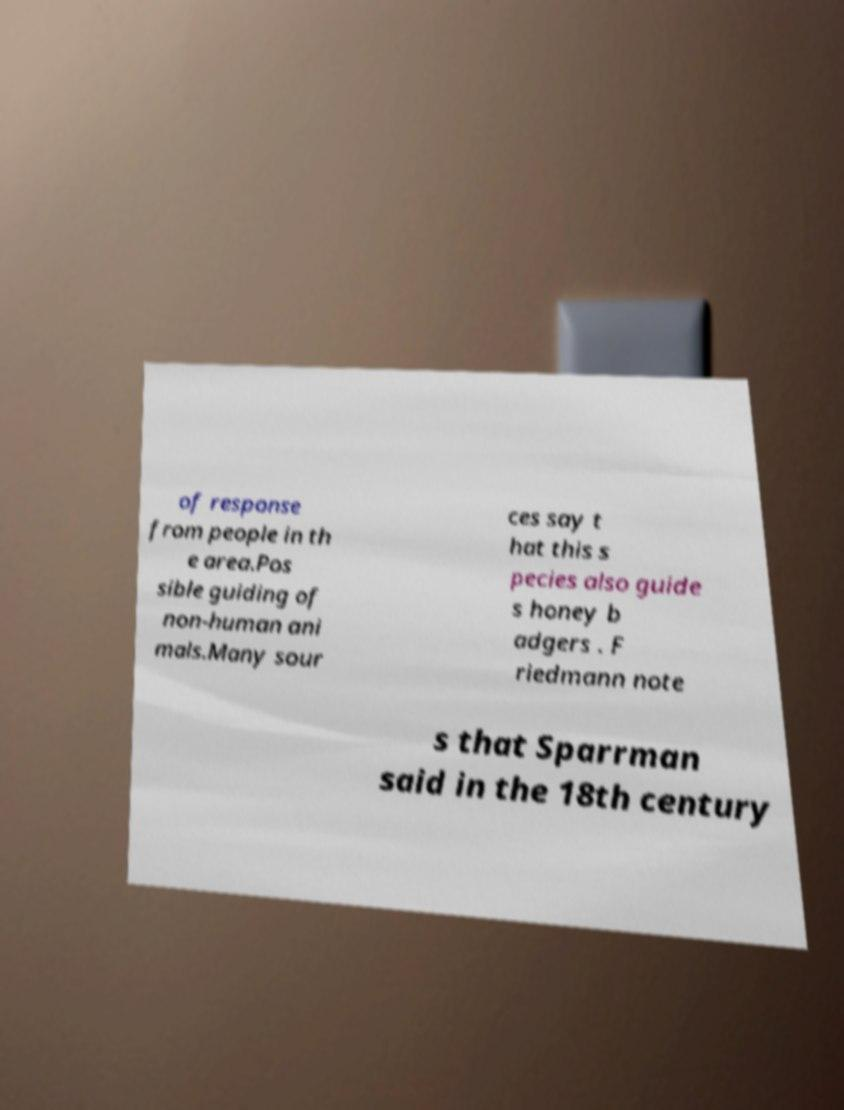Can you read and provide the text displayed in the image?This photo seems to have some interesting text. Can you extract and type it out for me? of response from people in th e area.Pos sible guiding of non-human ani mals.Many sour ces say t hat this s pecies also guide s honey b adgers . F riedmann note s that Sparrman said in the 18th century 